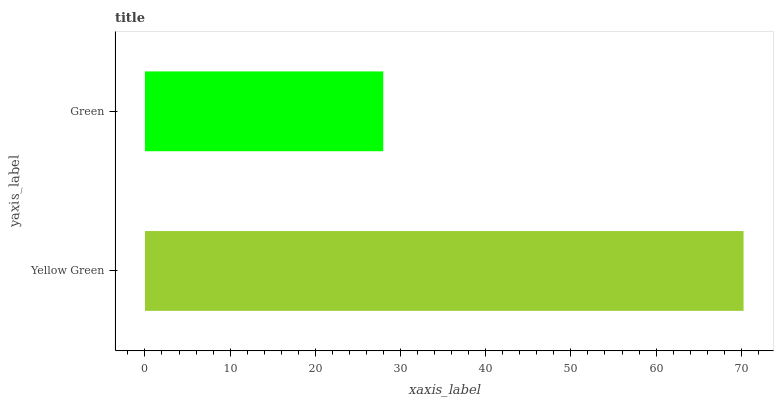Is Green the minimum?
Answer yes or no. Yes. Is Yellow Green the maximum?
Answer yes or no. Yes. Is Green the maximum?
Answer yes or no. No. Is Yellow Green greater than Green?
Answer yes or no. Yes. Is Green less than Yellow Green?
Answer yes or no. Yes. Is Green greater than Yellow Green?
Answer yes or no. No. Is Yellow Green less than Green?
Answer yes or no. No. Is Yellow Green the high median?
Answer yes or no. Yes. Is Green the low median?
Answer yes or no. Yes. Is Green the high median?
Answer yes or no. No. Is Yellow Green the low median?
Answer yes or no. No. 